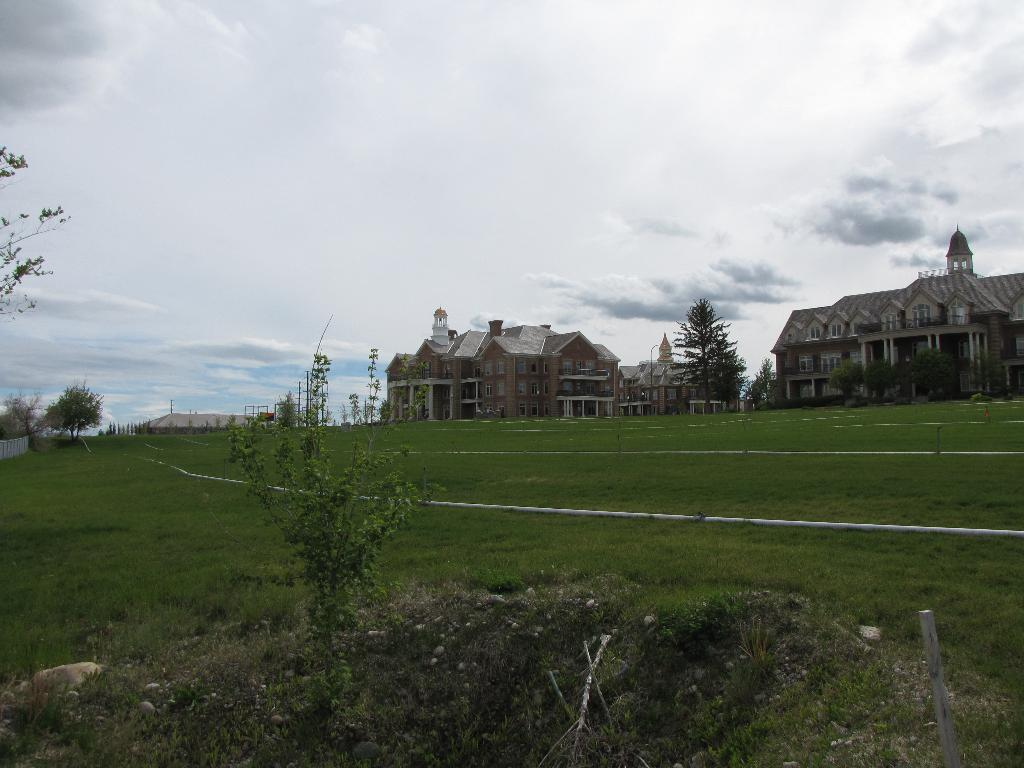What type of natural environment is visible in the image? There is grass and plants on the ground in the image. What can be seen in the distance behind the grass and plants? There are buildings in the background of the image. What part of the natural environment is visible in the image? The sky is visible in the background of the image. Where is the office located in the image? There is no office present in the image. What type of camp can be seen in the image? There is no camp present in the image. 